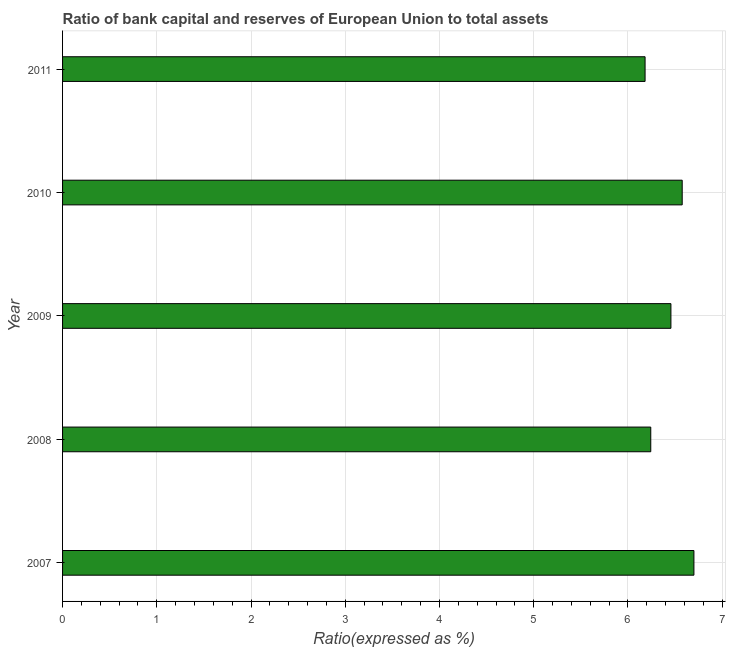What is the title of the graph?
Offer a terse response. Ratio of bank capital and reserves of European Union to total assets. What is the label or title of the X-axis?
Make the answer very short. Ratio(expressed as %). What is the label or title of the Y-axis?
Keep it short and to the point. Year. What is the bank capital to assets ratio in 2011?
Offer a terse response. 6.18. Across all years, what is the maximum bank capital to assets ratio?
Your response must be concise. 6.7. Across all years, what is the minimum bank capital to assets ratio?
Your response must be concise. 6.18. In which year was the bank capital to assets ratio minimum?
Offer a terse response. 2011. What is the sum of the bank capital to assets ratio?
Keep it short and to the point. 32.16. What is the difference between the bank capital to assets ratio in 2008 and 2011?
Ensure brevity in your answer.  0.06. What is the average bank capital to assets ratio per year?
Keep it short and to the point. 6.43. What is the median bank capital to assets ratio?
Provide a short and direct response. 6.46. In how many years, is the bank capital to assets ratio greater than 3 %?
Make the answer very short. 5. Do a majority of the years between 2011 and 2010 (inclusive) have bank capital to assets ratio greater than 1.6 %?
Your response must be concise. No. What is the ratio of the bank capital to assets ratio in 2007 to that in 2008?
Provide a short and direct response. 1.07. Is the bank capital to assets ratio in 2010 less than that in 2011?
Make the answer very short. No. What is the difference between the highest and the second highest bank capital to assets ratio?
Your answer should be very brief. 0.12. Is the sum of the bank capital to assets ratio in 2008 and 2011 greater than the maximum bank capital to assets ratio across all years?
Your answer should be very brief. Yes. What is the difference between the highest and the lowest bank capital to assets ratio?
Give a very brief answer. 0.52. How many bars are there?
Your answer should be compact. 5. Are all the bars in the graph horizontal?
Make the answer very short. Yes. How many years are there in the graph?
Provide a short and direct response. 5. What is the difference between two consecutive major ticks on the X-axis?
Give a very brief answer. 1. What is the Ratio(expressed as %) of 2007?
Keep it short and to the point. 6.7. What is the Ratio(expressed as %) of 2008?
Your answer should be compact. 6.24. What is the Ratio(expressed as %) in 2009?
Offer a very short reply. 6.46. What is the Ratio(expressed as %) of 2010?
Provide a short and direct response. 6.58. What is the Ratio(expressed as %) of 2011?
Provide a succinct answer. 6.18. What is the difference between the Ratio(expressed as %) in 2007 and 2008?
Your response must be concise. 0.46. What is the difference between the Ratio(expressed as %) in 2007 and 2009?
Provide a short and direct response. 0.24. What is the difference between the Ratio(expressed as %) in 2007 and 2010?
Your answer should be compact. 0.12. What is the difference between the Ratio(expressed as %) in 2007 and 2011?
Make the answer very short. 0.52. What is the difference between the Ratio(expressed as %) in 2008 and 2009?
Your answer should be compact. -0.21. What is the difference between the Ratio(expressed as %) in 2008 and 2010?
Give a very brief answer. -0.33. What is the difference between the Ratio(expressed as %) in 2008 and 2011?
Make the answer very short. 0.06. What is the difference between the Ratio(expressed as %) in 2009 and 2010?
Offer a terse response. -0.12. What is the difference between the Ratio(expressed as %) in 2009 and 2011?
Provide a succinct answer. 0.27. What is the difference between the Ratio(expressed as %) in 2010 and 2011?
Provide a succinct answer. 0.39. What is the ratio of the Ratio(expressed as %) in 2007 to that in 2008?
Provide a succinct answer. 1.07. What is the ratio of the Ratio(expressed as %) in 2007 to that in 2009?
Make the answer very short. 1.04. What is the ratio of the Ratio(expressed as %) in 2007 to that in 2010?
Make the answer very short. 1.02. What is the ratio of the Ratio(expressed as %) in 2007 to that in 2011?
Provide a succinct answer. 1.08. What is the ratio of the Ratio(expressed as %) in 2008 to that in 2010?
Provide a short and direct response. 0.95. What is the ratio of the Ratio(expressed as %) in 2008 to that in 2011?
Your response must be concise. 1.01. What is the ratio of the Ratio(expressed as %) in 2009 to that in 2011?
Provide a succinct answer. 1.04. What is the ratio of the Ratio(expressed as %) in 2010 to that in 2011?
Your answer should be very brief. 1.06. 